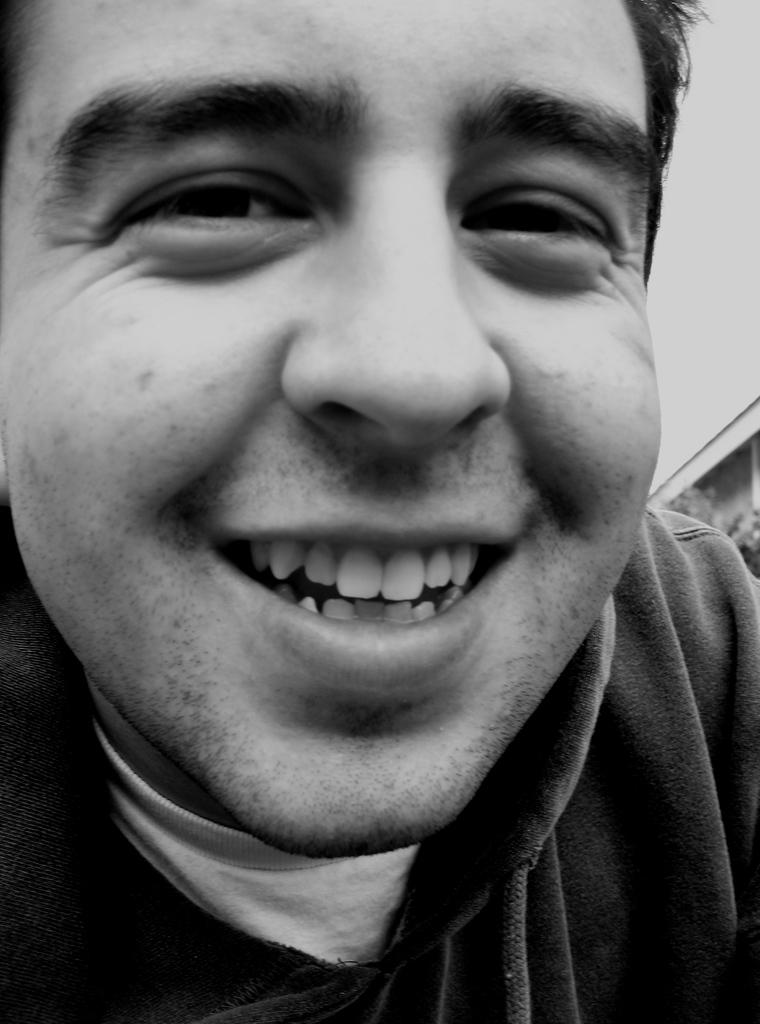What is the color scheme of the image? The image is black and white. Who is present in the image? There is a man in the image. What is the man doing in the image? The man is smiling. What type of steel is the man holding in the image? There is no steel present in the image; it is a black and white image of a man smiling. 